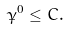Convert formula to latex. <formula><loc_0><loc_0><loc_500><loc_500>\dot { \gamma } ^ { 0 } \leq C .</formula> 